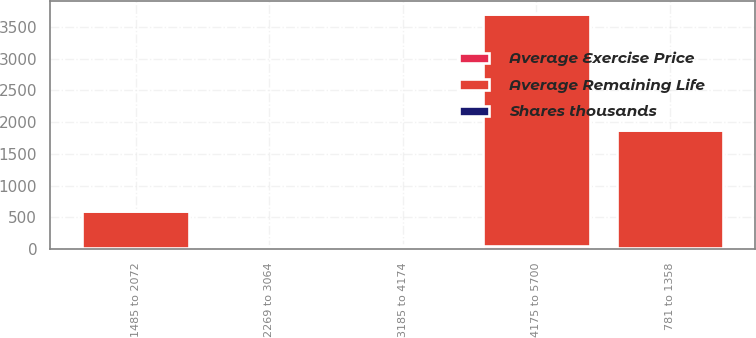Convert chart. <chart><loc_0><loc_0><loc_500><loc_500><stacked_bar_chart><ecel><fcel>781 to 1358<fcel>1485 to 2072<fcel>2269 to 3064<fcel>3185 to 4174<fcel>4175 to 5700<nl><fcel>Average Remaining Life<fcel>1869<fcel>589<fcel>16.08<fcel>16.08<fcel>3661<nl><fcel>Average Exercise Price<fcel>11.14<fcel>16.08<fcel>25.01<fcel>35.46<fcel>48.51<nl><fcel>Shares thousands<fcel>2<fcel>3<fcel>6<fcel>8<fcel>9<nl></chart> 